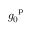<formula> <loc_0><loc_0><loc_500><loc_500>g _ { 0 } ^ { p }</formula> 